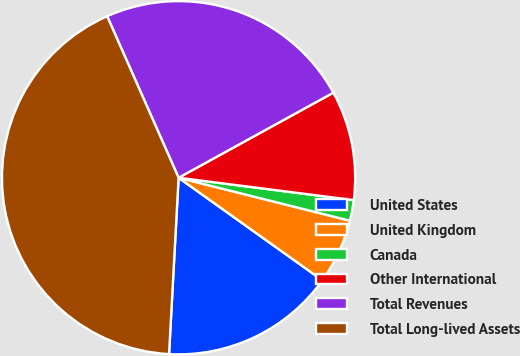Convert chart to OTSL. <chart><loc_0><loc_0><loc_500><loc_500><pie_chart><fcel>United States<fcel>United Kingdom<fcel>Canada<fcel>Other International<fcel>Total Revenues<fcel>Total Long-lived Assets<nl><fcel>16.0%<fcel>5.95%<fcel>1.89%<fcel>10.02%<fcel>23.63%<fcel>42.51%<nl></chart> 